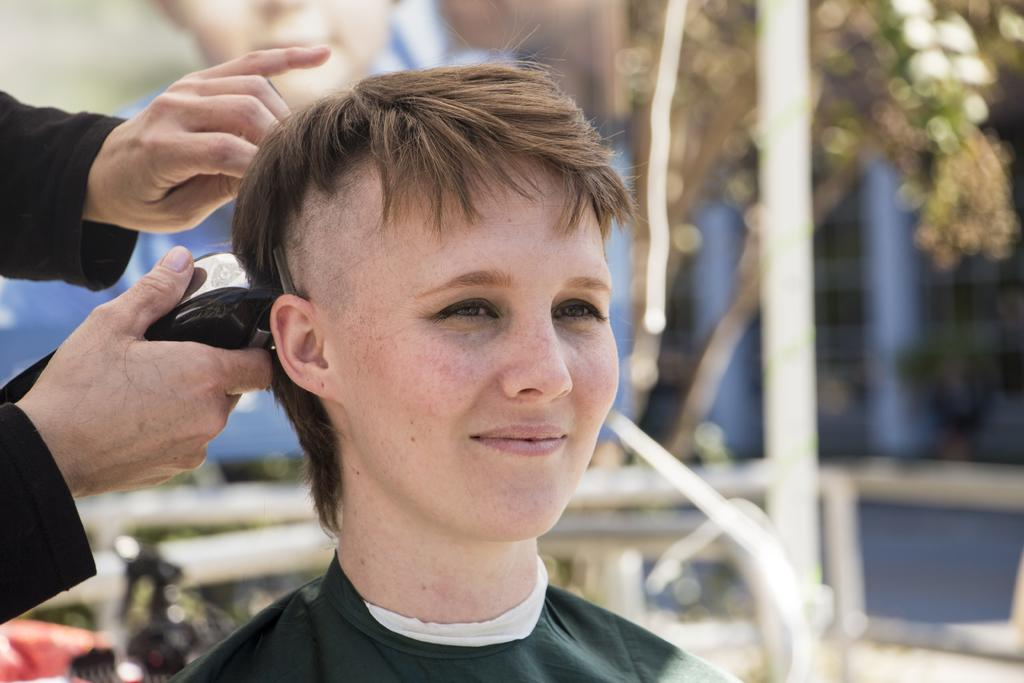What is the main subject in the foreground of the picture? There is a woman in the foreground of the picture. What is the person on the left side of the picture holding? The person is holding a trimmer on the left side of the picture. What can be seen in the background of the picture? There are trees, poles, and other objects in the background of the picture. How many clover leaves can be seen in the image? There is no clover present in the image, so it is not possible to determine the number of leaves. What type of dock is visible in the image? There is no dock present in the image. 